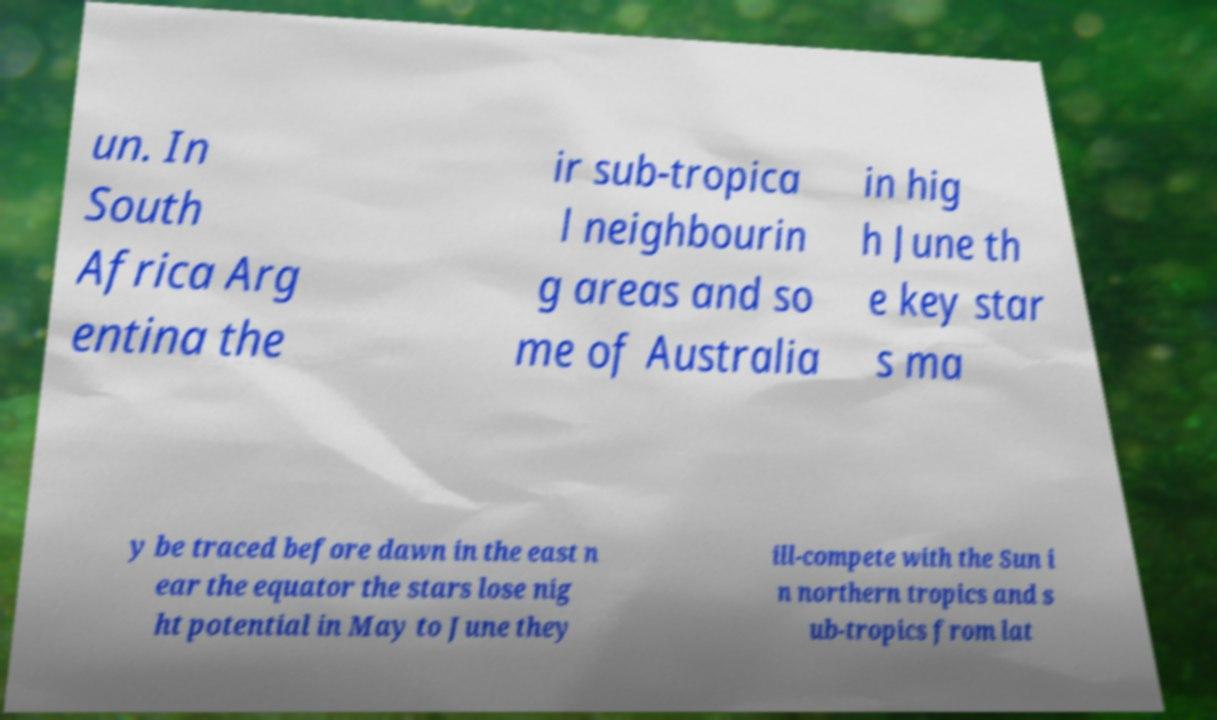I need the written content from this picture converted into text. Can you do that? un. In South Africa Arg entina the ir sub-tropica l neighbourin g areas and so me of Australia in hig h June th e key star s ma y be traced before dawn in the east n ear the equator the stars lose nig ht potential in May to June they ill-compete with the Sun i n northern tropics and s ub-tropics from lat 